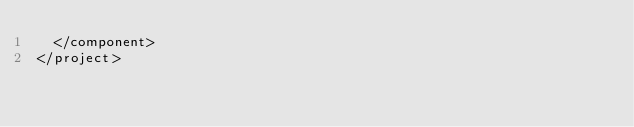<code> <loc_0><loc_0><loc_500><loc_500><_XML_>  </component>
</project></code> 